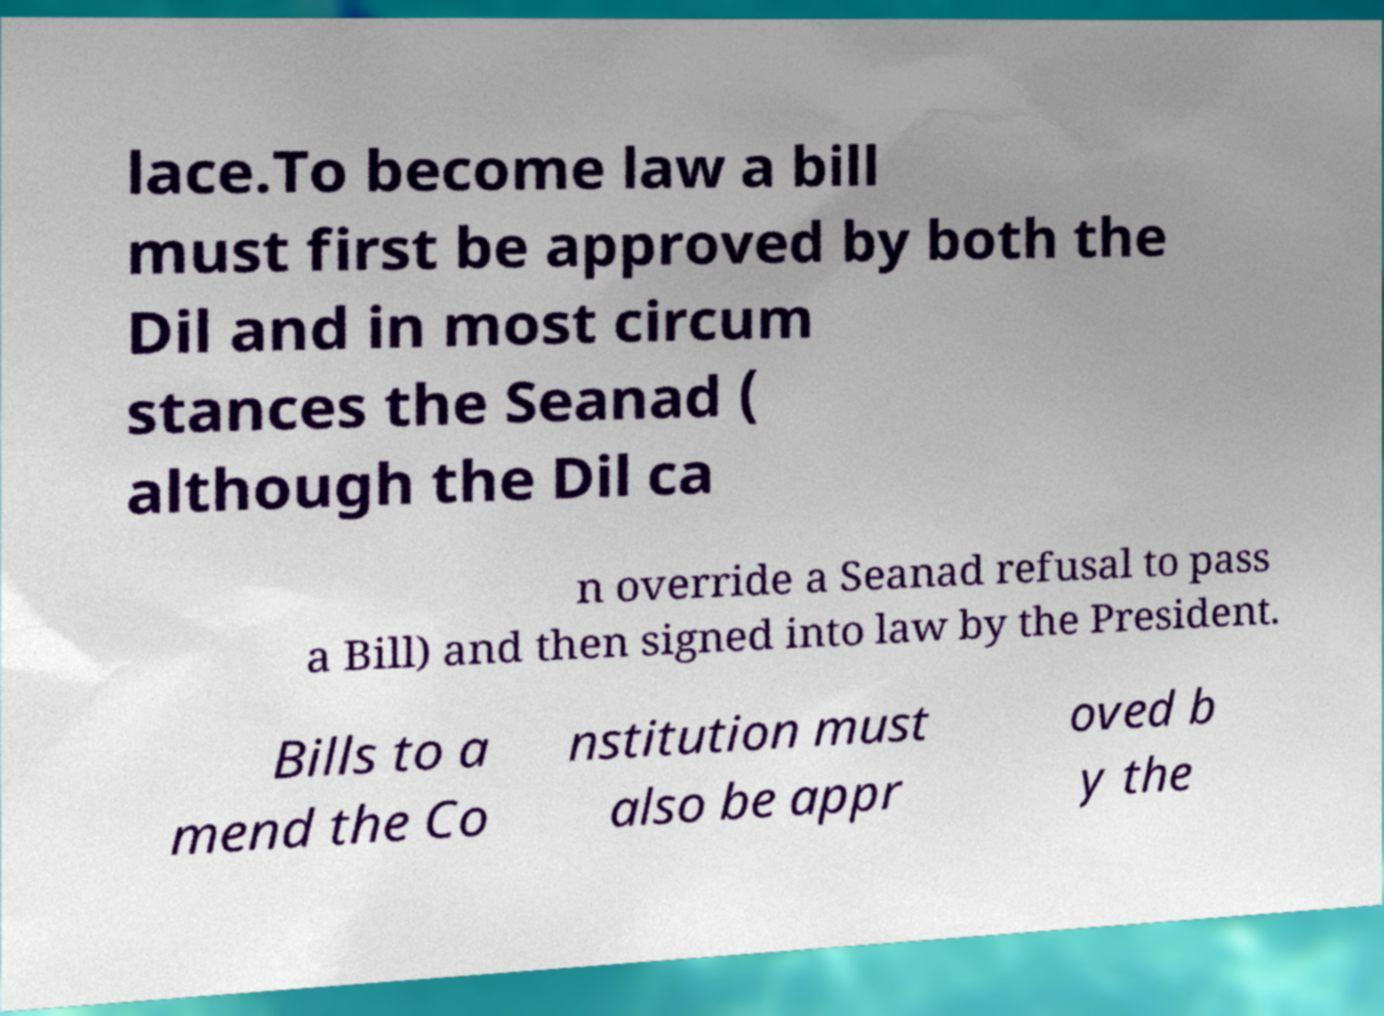What messages or text are displayed in this image? I need them in a readable, typed format. lace.To become law a bill must first be approved by both the Dil and in most circum stances the Seanad ( although the Dil ca n override a Seanad refusal to pass a Bill) and then signed into law by the President. Bills to a mend the Co nstitution must also be appr oved b y the 